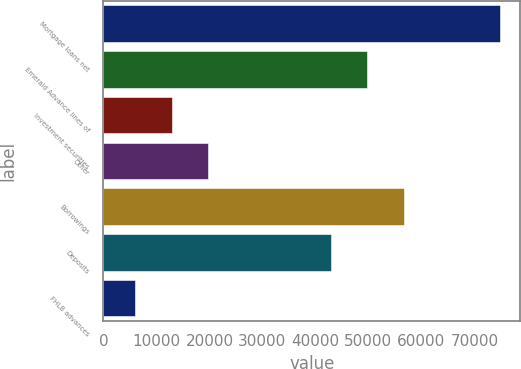<chart> <loc_0><loc_0><loc_500><loc_500><bar_chart><fcel>Mortgage loans net<fcel>Emerald Advance lines of<fcel>Investment securities<fcel>Other<fcel>Borrowings<fcel>Deposits<fcel>FHLB advances<nl><fcel>74895<fcel>49766.7<fcel>12896.7<fcel>19785.4<fcel>56655.4<fcel>42878<fcel>6008<nl></chart> 